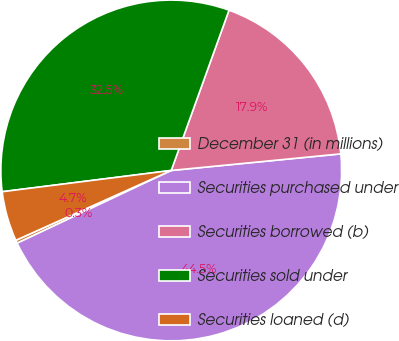<chart> <loc_0><loc_0><loc_500><loc_500><pie_chart><fcel>December 31 (in millions)<fcel>Securities purchased under<fcel>Securities borrowed (b)<fcel>Securities sold under<fcel>Securities loaned (d)<nl><fcel>0.3%<fcel>44.53%<fcel>17.94%<fcel>32.5%<fcel>4.73%<nl></chart> 